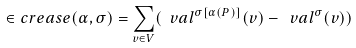Convert formula to latex. <formula><loc_0><loc_0><loc_500><loc_500>\in c r e a s e ( \alpha , \sigma ) = \sum _ { v \in V } ( \ v a l ^ { \sigma [ \alpha ( P ) ] } ( v ) - \ v a l ^ { \sigma } ( v ) )</formula> 